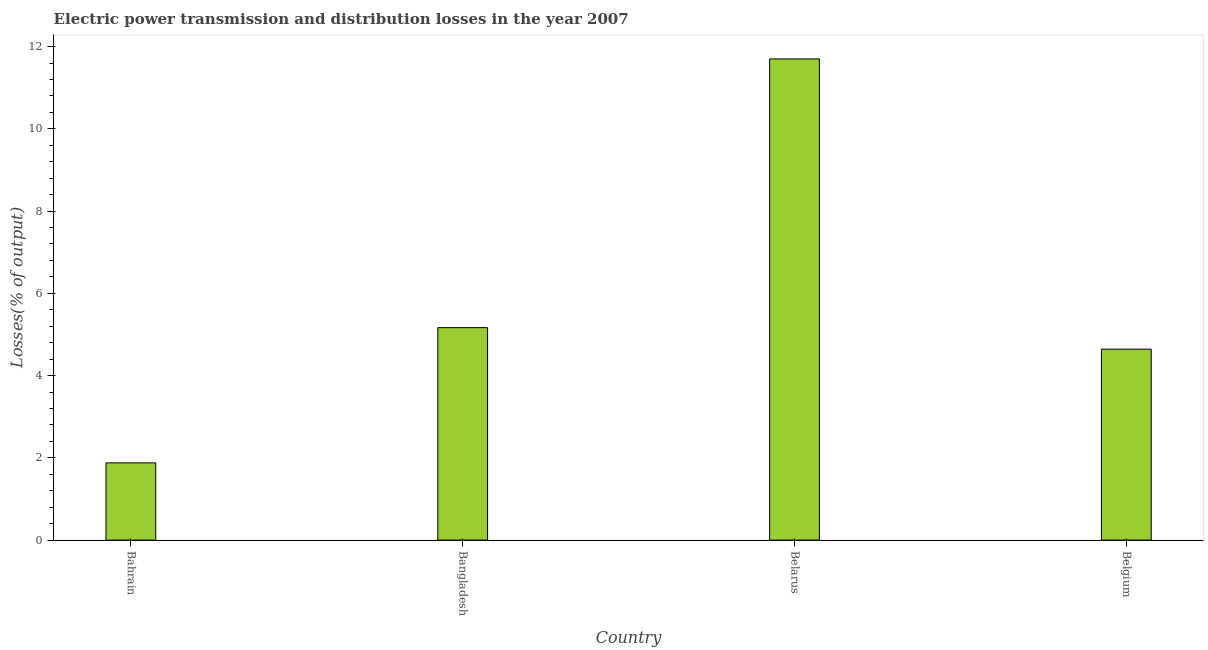What is the title of the graph?
Provide a succinct answer. Electric power transmission and distribution losses in the year 2007. What is the label or title of the Y-axis?
Your response must be concise. Losses(% of output). What is the electric power transmission and distribution losses in Belgium?
Keep it short and to the point. 4.64. Across all countries, what is the maximum electric power transmission and distribution losses?
Your answer should be compact. 11.7. Across all countries, what is the minimum electric power transmission and distribution losses?
Offer a terse response. 1.88. In which country was the electric power transmission and distribution losses maximum?
Your answer should be very brief. Belarus. In which country was the electric power transmission and distribution losses minimum?
Keep it short and to the point. Bahrain. What is the sum of the electric power transmission and distribution losses?
Provide a succinct answer. 23.39. What is the difference between the electric power transmission and distribution losses in Bahrain and Belgium?
Give a very brief answer. -2.77. What is the average electric power transmission and distribution losses per country?
Keep it short and to the point. 5.85. What is the median electric power transmission and distribution losses?
Provide a short and direct response. 4.9. In how many countries, is the electric power transmission and distribution losses greater than 4 %?
Your answer should be compact. 3. What is the ratio of the electric power transmission and distribution losses in Bahrain to that in Bangladesh?
Keep it short and to the point. 0.36. Is the difference between the electric power transmission and distribution losses in Bahrain and Belgium greater than the difference between any two countries?
Offer a very short reply. No. What is the difference between the highest and the second highest electric power transmission and distribution losses?
Give a very brief answer. 6.53. Is the sum of the electric power transmission and distribution losses in Bangladesh and Belarus greater than the maximum electric power transmission and distribution losses across all countries?
Ensure brevity in your answer.  Yes. What is the difference between the highest and the lowest electric power transmission and distribution losses?
Keep it short and to the point. 9.82. How many countries are there in the graph?
Make the answer very short. 4. What is the Losses(% of output) of Bahrain?
Make the answer very short. 1.88. What is the Losses(% of output) of Bangladesh?
Make the answer very short. 5.17. What is the Losses(% of output) of Belarus?
Keep it short and to the point. 11.7. What is the Losses(% of output) of Belgium?
Offer a very short reply. 4.64. What is the difference between the Losses(% of output) in Bahrain and Bangladesh?
Ensure brevity in your answer.  -3.29. What is the difference between the Losses(% of output) in Bahrain and Belarus?
Your answer should be compact. -9.82. What is the difference between the Losses(% of output) in Bahrain and Belgium?
Your response must be concise. -2.76. What is the difference between the Losses(% of output) in Bangladesh and Belarus?
Ensure brevity in your answer.  -6.53. What is the difference between the Losses(% of output) in Bangladesh and Belgium?
Keep it short and to the point. 0.52. What is the difference between the Losses(% of output) in Belarus and Belgium?
Your response must be concise. 7.06. What is the ratio of the Losses(% of output) in Bahrain to that in Bangladesh?
Your response must be concise. 0.36. What is the ratio of the Losses(% of output) in Bahrain to that in Belarus?
Ensure brevity in your answer.  0.16. What is the ratio of the Losses(% of output) in Bahrain to that in Belgium?
Provide a short and direct response. 0.41. What is the ratio of the Losses(% of output) in Bangladesh to that in Belarus?
Your response must be concise. 0.44. What is the ratio of the Losses(% of output) in Bangladesh to that in Belgium?
Provide a succinct answer. 1.11. What is the ratio of the Losses(% of output) in Belarus to that in Belgium?
Keep it short and to the point. 2.52. 